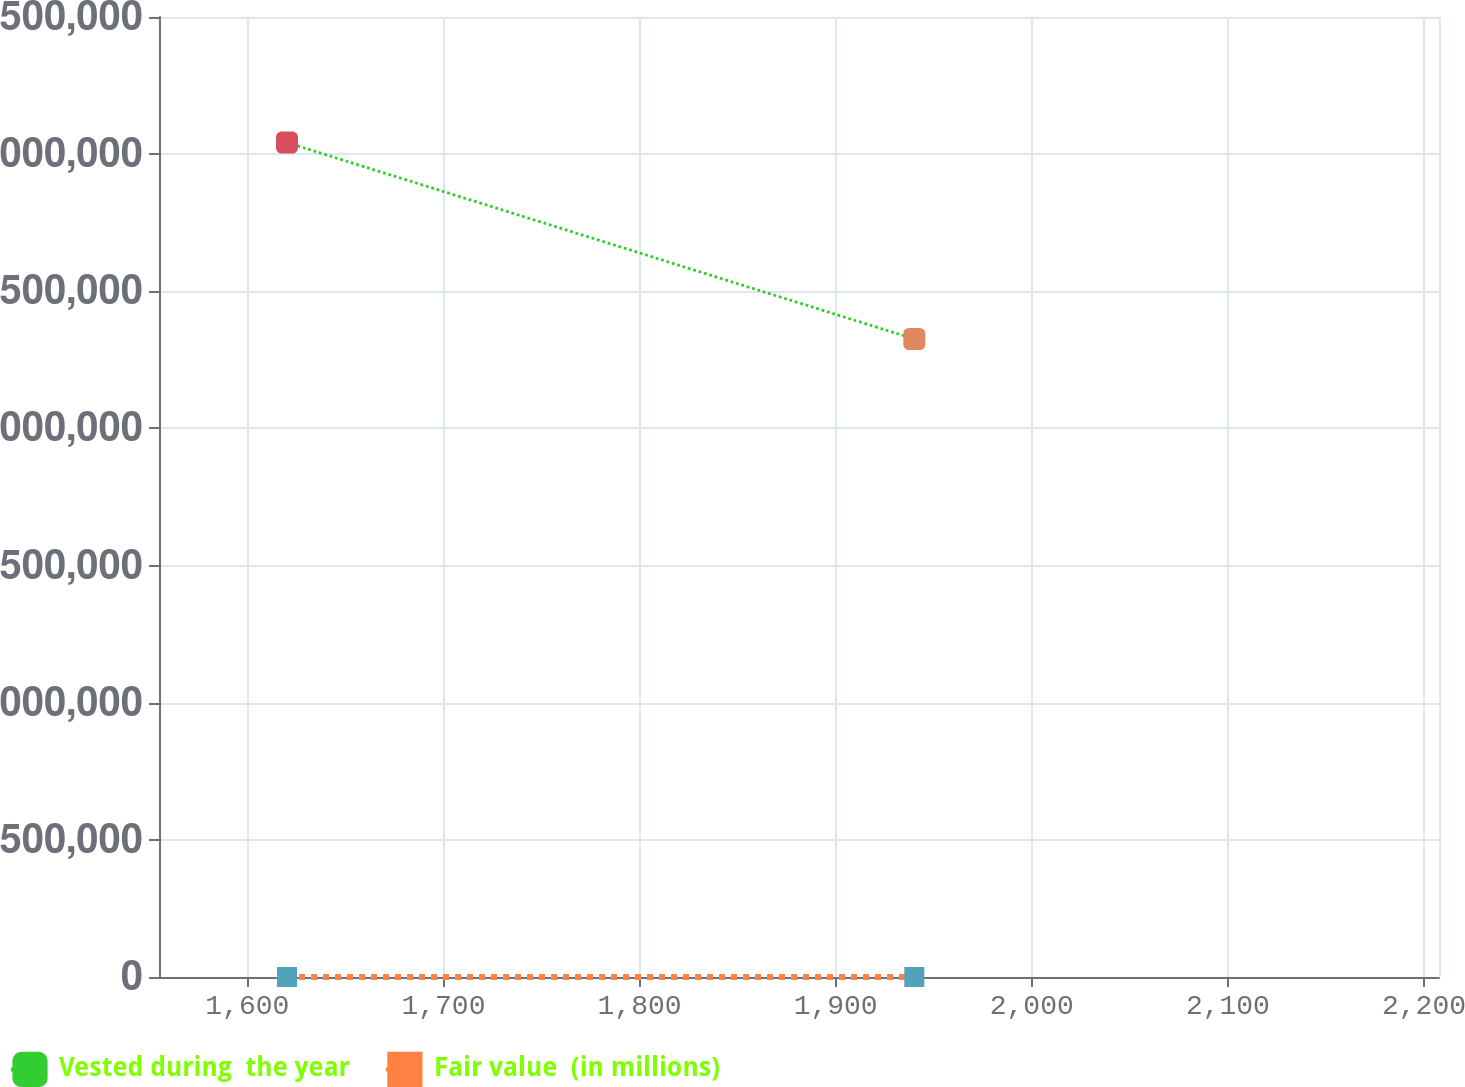<chart> <loc_0><loc_0><loc_500><loc_500><line_chart><ecel><fcel>Vested during  the year<fcel>Fair value  (in millions)<nl><fcel>1620.23<fcel>3.04233e+06<fcel>68.49<nl><fcel>1940.11<fcel>2.32606e+06<fcel>59.32<nl><fcel>2272.92<fcel>2.75311e+06<fcel>70.79<nl></chart> 